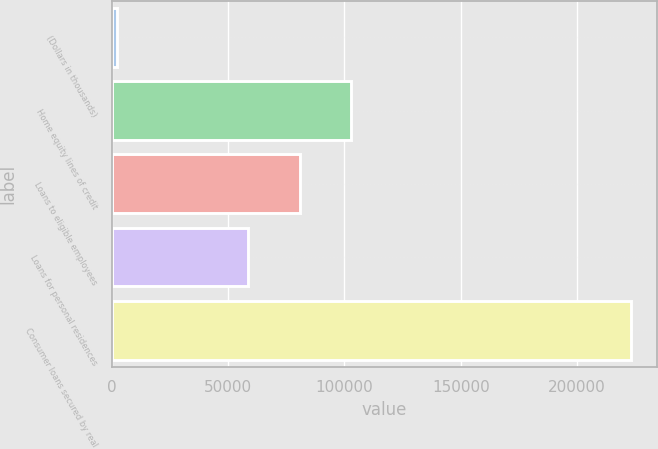Convert chart. <chart><loc_0><loc_0><loc_500><loc_500><bar_chart><fcel>(Dollars in thousands)<fcel>Home equity lines of credit<fcel>Loans to eligible employees<fcel>Loans for personal residences<fcel>Consumer loans secured by real<nl><fcel>2008<fcel>102899<fcel>80799.5<fcel>58700<fcel>223003<nl></chart> 